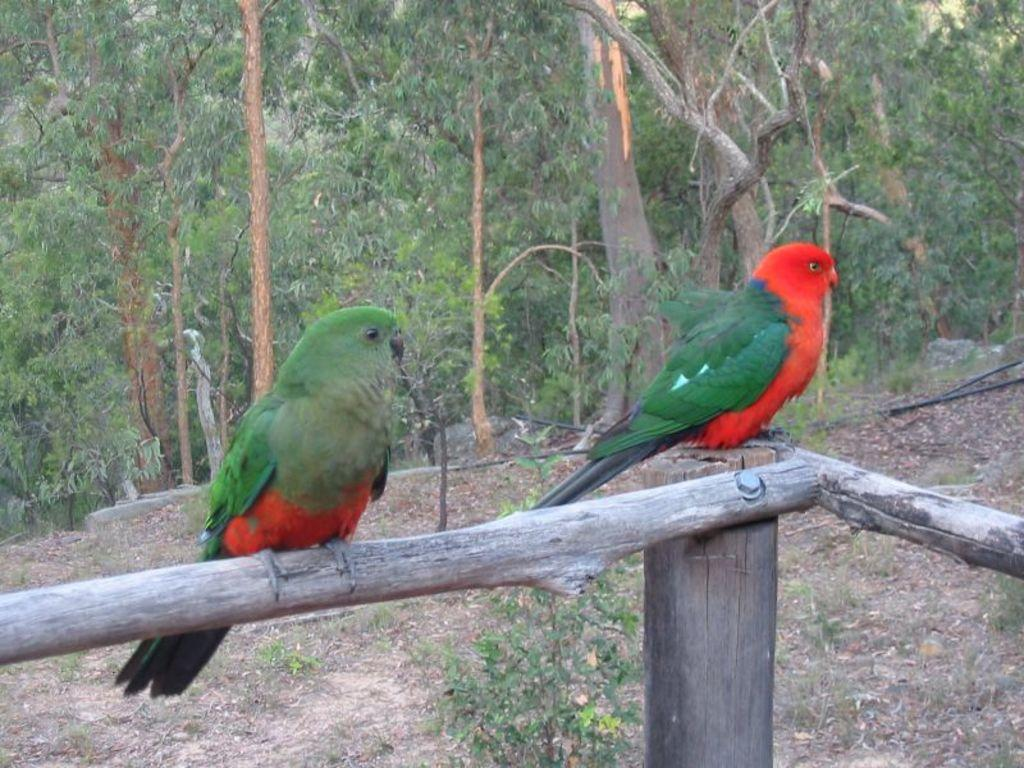What animals are on wooden poles in the image? There are parrots on wooden poles in the image. What other living organisms can be seen in the image? There are plants visible in the image. What type of vegetation is in the background of the image? There are trees in the background of the image. What type of chalk is being used by the parrots in the image? There is no chalk present in the image; the parrots are on wooden poles and not using any chalk. 